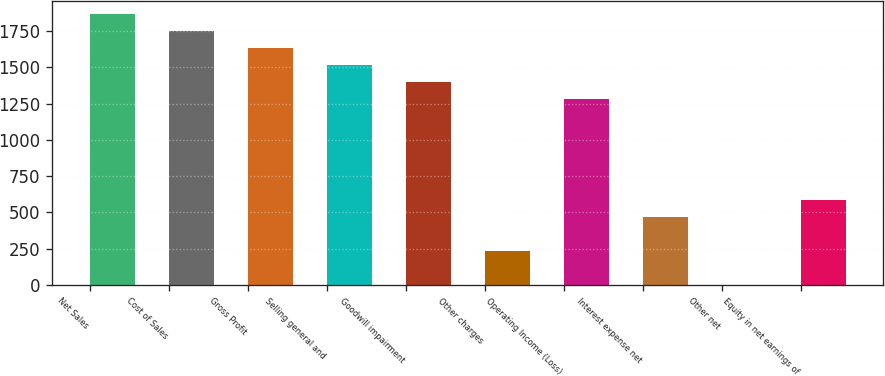Convert chart. <chart><loc_0><loc_0><loc_500><loc_500><bar_chart><fcel>Net Sales<fcel>Cost of Sales<fcel>Gross Profit<fcel>Selling general and<fcel>Goodwill impairment<fcel>Other charges<fcel>Operating Income (Loss)<fcel>Interest expense net<fcel>Other net<fcel>Equity in net earnings of<nl><fcel>1866.6<fcel>1750<fcel>1633.4<fcel>1516.8<fcel>1400.2<fcel>234.2<fcel>1283.6<fcel>467.4<fcel>1<fcel>584<nl></chart> 